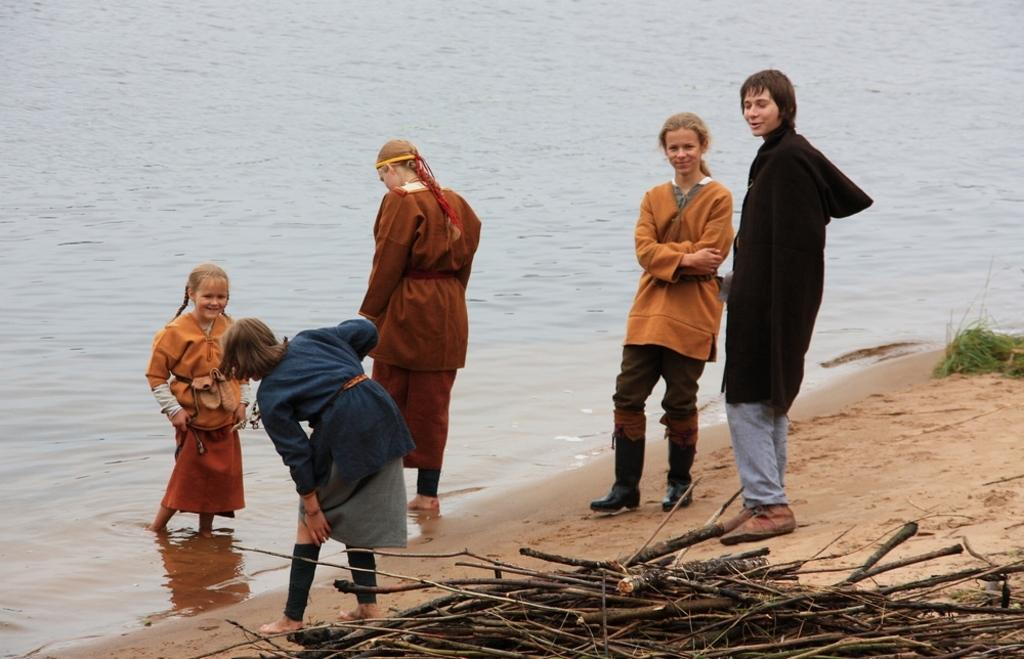How many people are in the image? There is a group of persons standing in the image. What can be seen at the bottom of the image? There are wooden sticks visible at the bottom of the image. What is visible in the background of the image? There is water visible in the background of the image. What type of map is being used by the group of persons in the image? There is no map present in the image; it only shows a group of persons standing and wooden sticks at the bottom. 